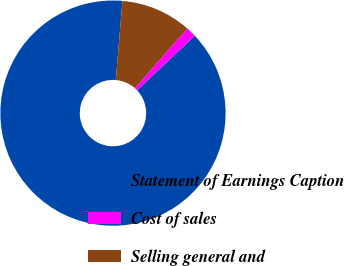Convert chart to OTSL. <chart><loc_0><loc_0><loc_500><loc_500><pie_chart><fcel>Statement of Earnings Caption<fcel>Cost of sales<fcel>Selling general and<nl><fcel>88.39%<fcel>1.46%<fcel>10.15%<nl></chart> 